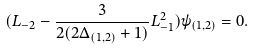Convert formula to latex. <formula><loc_0><loc_0><loc_500><loc_500>( L _ { - 2 } - \frac { 3 } { 2 ( 2 \Delta _ { ( 1 , 2 ) } + 1 ) } L _ { - 1 } ^ { 2 } ) \psi _ { ( 1 , 2 ) } = 0 .</formula> 